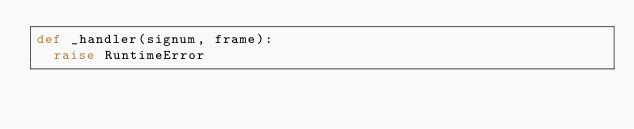Convert code to text. <code><loc_0><loc_0><loc_500><loc_500><_Python_>def _handler(signum, frame):
	raise RuntimeError</code> 